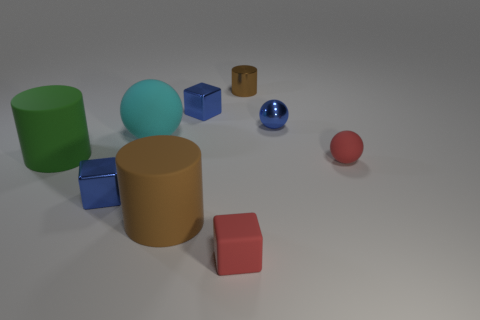Add 1 big purple cylinders. How many objects exist? 10 Subtract all spheres. How many objects are left? 6 Add 3 gray matte blocks. How many gray matte blocks exist? 3 Subtract 0 gray cylinders. How many objects are left? 9 Subtract all green cylinders. Subtract all tiny metal objects. How many objects are left? 4 Add 2 red matte blocks. How many red matte blocks are left? 3 